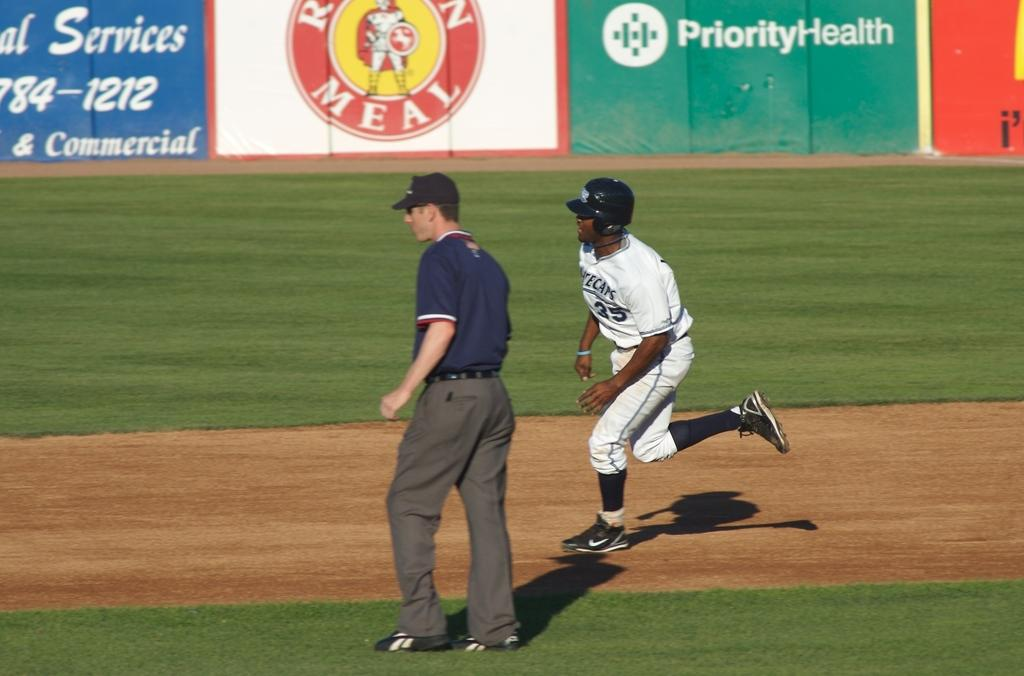<image>
Describe the image concisely. A baseball player is running by a referee in front of an ad for Priority Health. 